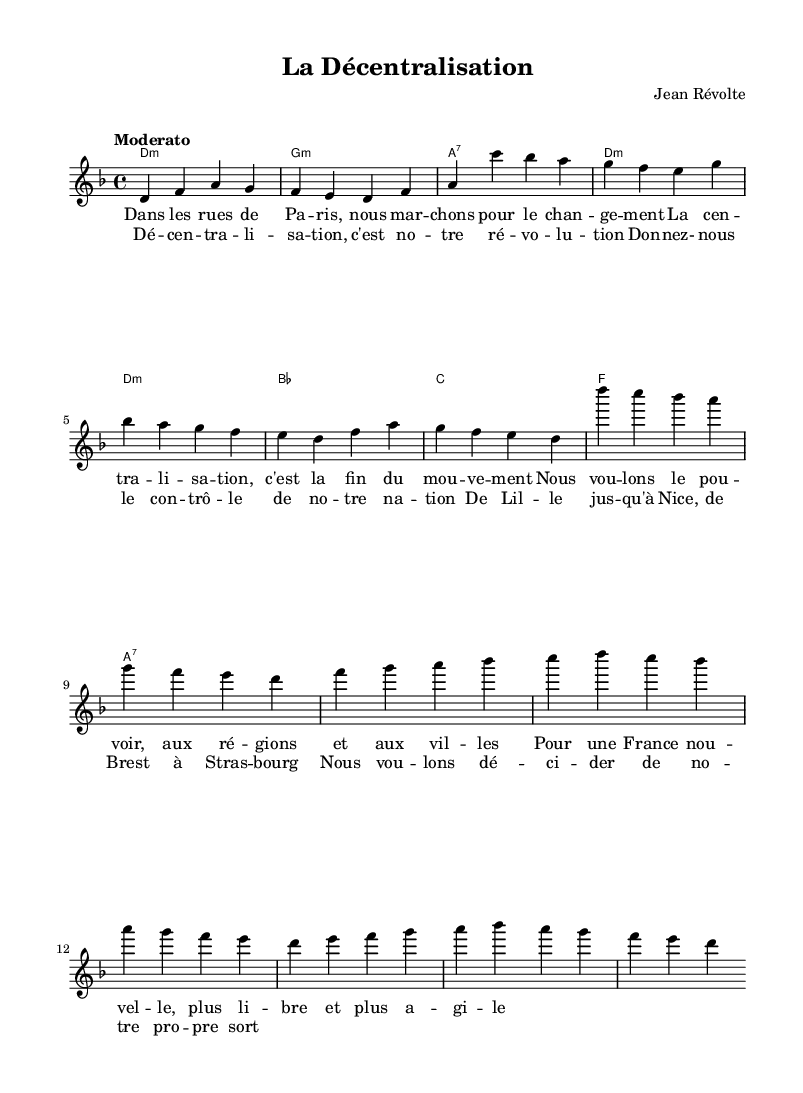What is the key signature of this music? The key signature is indicated at the beginning of the piece and specifies the sharps or flats used throughout. In this case, the piece is in D minor, which has one flat, B♭.
Answer: D minor What is the time signature of this music? The time signature appears at the beginning of the score, indicating how many beats are in each measure. Here, it is 4/4, meaning there are four beats per measure, and each beat is a quarter note.
Answer: 4/4 What is the title of this piece? The title is shown in the header section of the sheet music. It is typically the most prominent text at the top of the page. The title here is "La Décentralisation."
Answer: La Décentralisation Who is the composer of this music? The composer is also stated in the header section, under the title. It identifies who wrote the piece. In this case, the composer is "Jean Révolte."
Answer: Jean Révolte What is the tempo marking for this piece? The tempo marking is located near the beginning and indicates the speed at which the music should be played. Here, it is marked as "Moderato," suggesting a moderate tempo.
Answer: Moderato What is the structure of the lyrics in this song? The lyrics can be broken down into distinct sections. The sheet music shows a verse followed by a chorus. The alternating sections create a typical song structure commonly found in protest songs.
Answer: Verse and Chorus How does this song relate to the theme of decentralization? The song's lyrics explicitly focus on the desire for decentralization, mentioning the power to the regions and advocating for a new France. This reflects the political context of the time and addresses the call for political reforms and regional empowerment.
Answer: It advocates for political reforms 